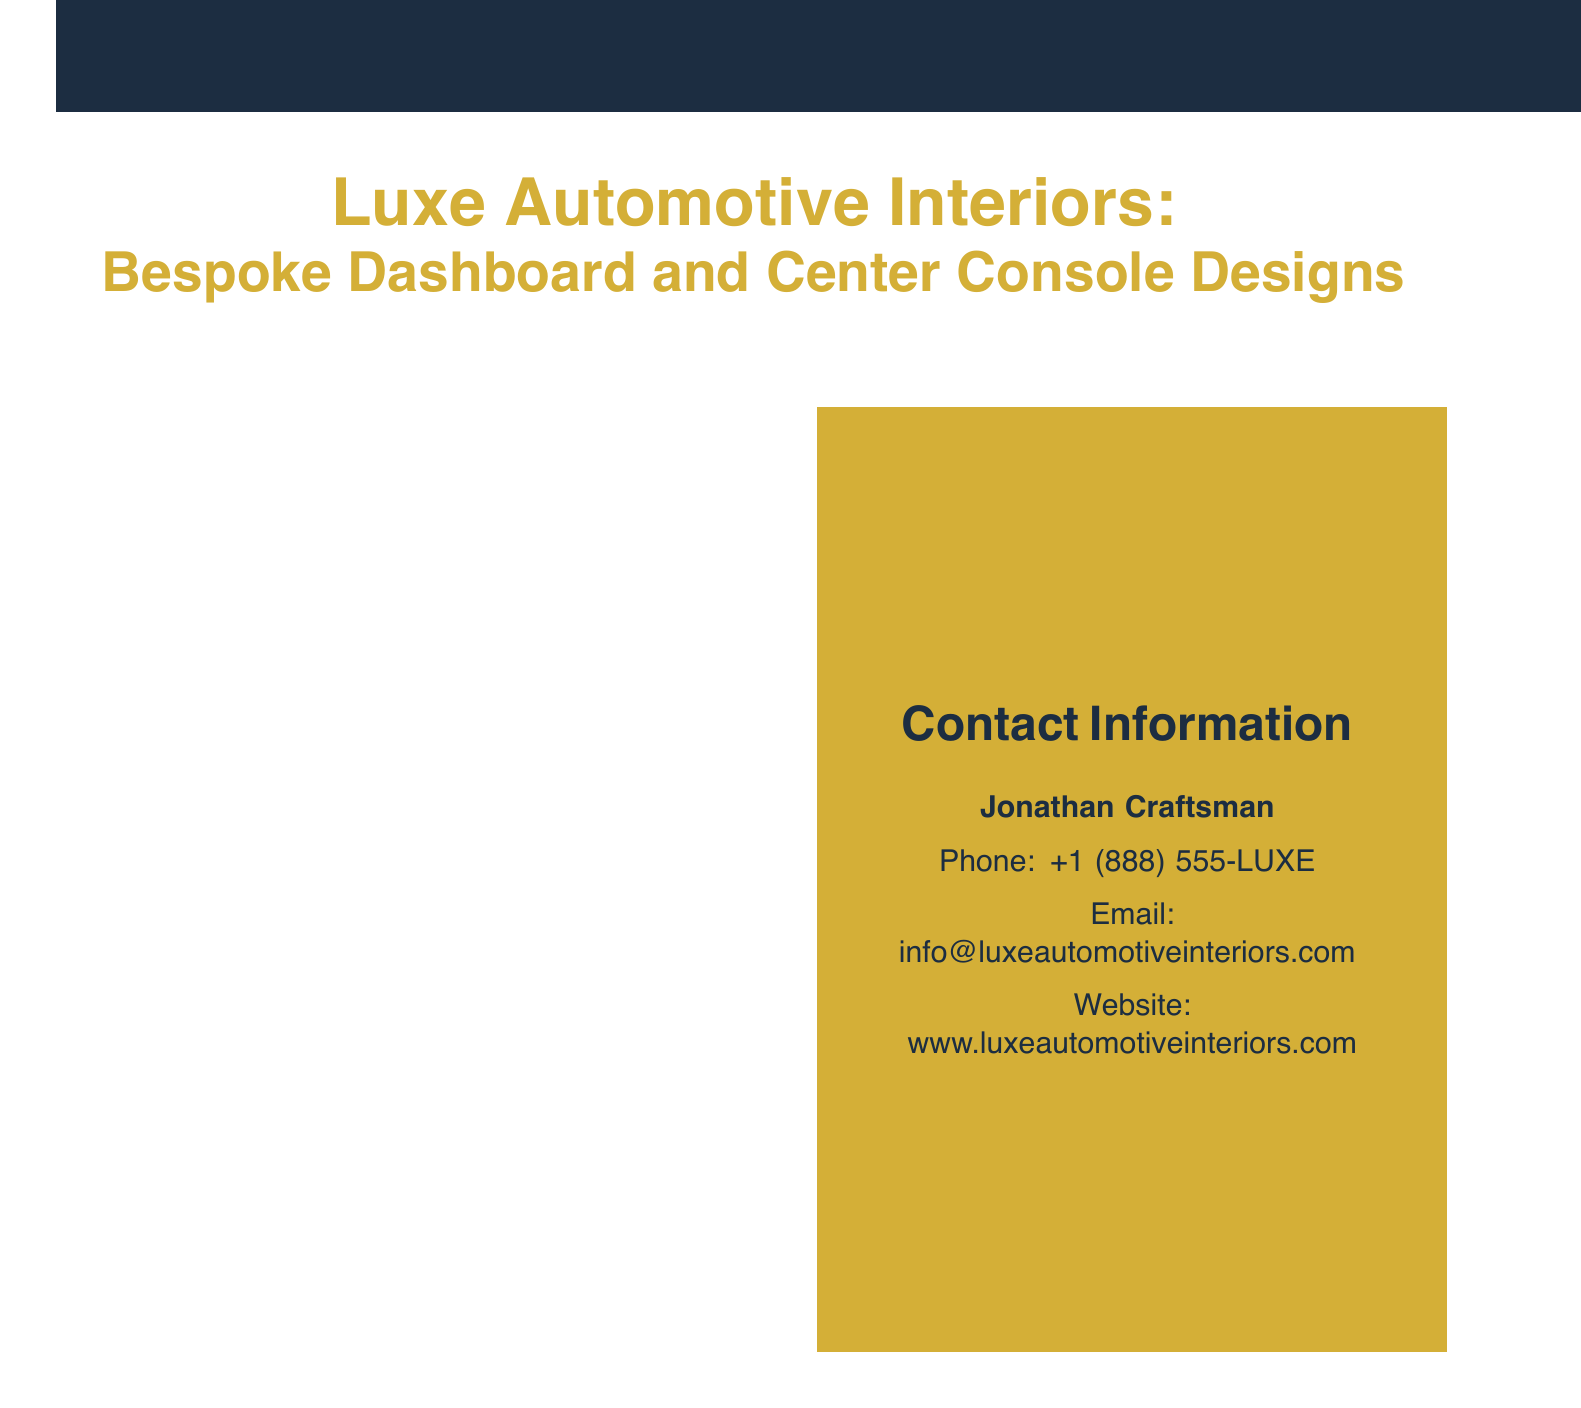What is the name of the color used for the main text? The main text color is identified in the document as luxegold.
Answer: luxegold How many premium finishes are listed? The document lists four premium finishes under the Premium Finishes section.
Answer: 4 What is one of the signature designs mentioned? The document includes specific examples of signature designs, one of which is the Bentley-inspired 'Flying B' Console.
Answer: Bentley-inspired 'Flying B' Console What feature can be personalized according to customization options? The document states that one of the customization options includes personalized monograms.
Answer: Personalized Monograms What type of finish is described as "Satin-Finish Piano Black"? This is a specific type mentioned under Premium Finishes, highlighting its glossy appearance.
Answer: Satin-Finish Piano Black Who is the contact person for inquiries? The document specifies Jonathan Craftsman as the contact person for the business.
Answer: Jonathan Craftsman What innovative texture includes "Quilted Diamond Stitch Leather"? This texture is mentioned as part of the Innovative Textures section in the catalog.
Answer: Quilted Diamond Stitch Leather What is the phone number provided for contact? The contact phone number provided in the document is +1 (888) 555-LUXE.
Answer: +1 (888) 555-LUXE 